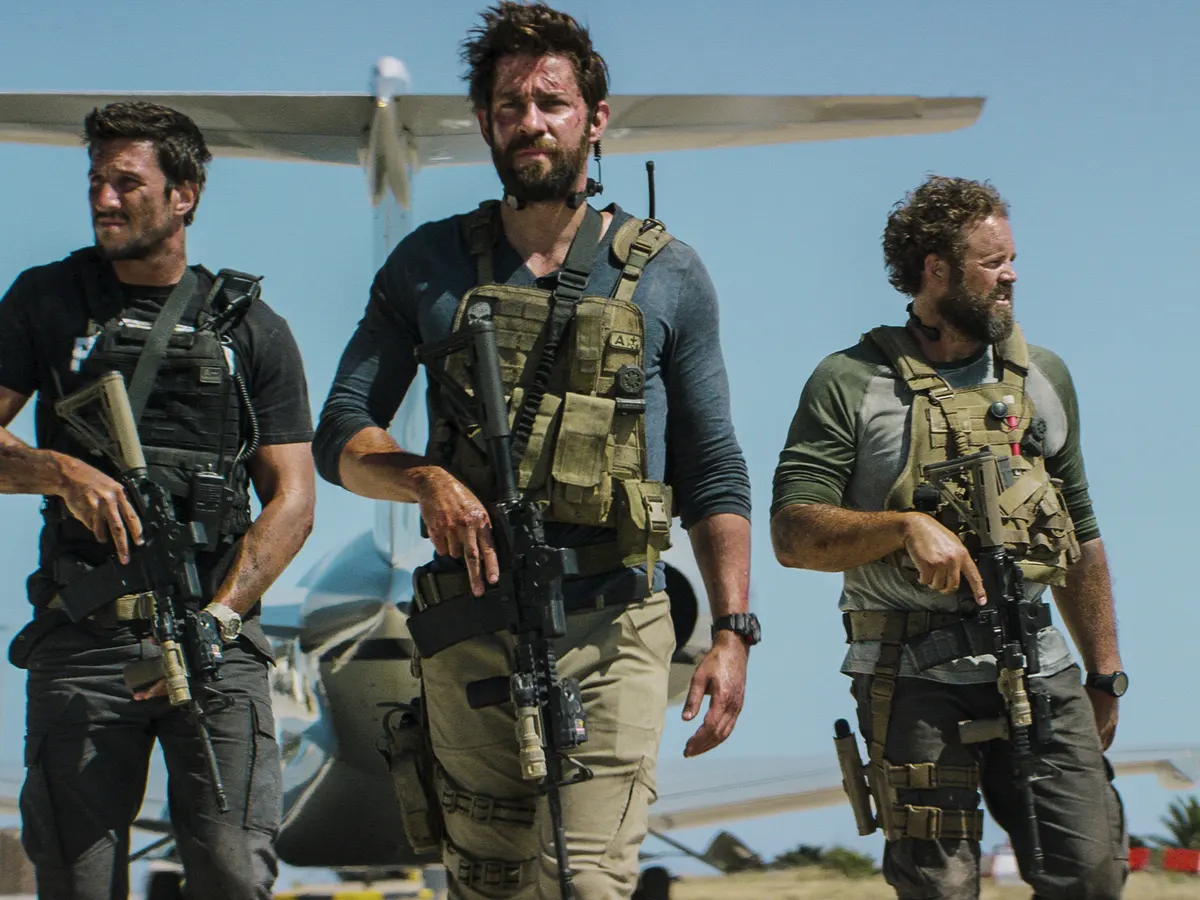Do you think they are a part of a larger operation? How could this scene tie into a bigger narrative? It is highly plausible that they are part of a larger operation. This scene could be a critical moment in a broader mission involving multiple squads working in coordination. They might be the extraction team sent in to retrieve vital intelligence or personnel, while other units create diversions or secure the perimeter. This moment could be the climax where all efforts converge, tying into a bigger narrative of covert operations, geopolitical tensions, or a rescue mission against considerable odds. The wider storyline could delve into the preparation, execution, and aftermath of their mission, highlighting the personal stakes and broader implications of their actions. What kind of personal backgrounds could these men have? Each of these men could have rich and varied personal backgrounds that contribute to their current roles. The central figure might be a former military officer with extensive combat experience and leadership skills, driven by a deep sense of duty and resilience. The man on the left could be a technology expert or communications specialist, applying his intricate knowledge of tactical systems and field devices, possibly spurred by a personal quest for justice or redemption. The third individual might have been an elite athlete or survivalist, whose physical prowess and tenacity make him invaluable in high-risk missions. Their diverse backgrounds meld together, creating a formidable team fueled by unique motivations and shared trust. 